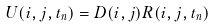<formula> <loc_0><loc_0><loc_500><loc_500>U ( i , j , t _ { n } ) = D ( i , j ) R ( i , j , t _ { n } )</formula> 